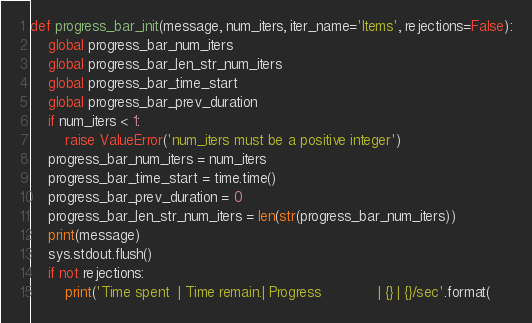Convert code to text. <code><loc_0><loc_0><loc_500><loc_500><_Python_>

def progress_bar_init(message, num_iters, iter_name='Items', rejections=False):
    global progress_bar_num_iters
    global progress_bar_len_str_num_iters
    global progress_bar_time_start
    global progress_bar_prev_duration
    if num_iters < 1:
        raise ValueError('num_iters must be a positive integer')
    progress_bar_num_iters = num_iters
    progress_bar_time_start = time.time()
    progress_bar_prev_duration = 0
    progress_bar_len_str_num_iters = len(str(progress_bar_num_iters))
    print(message)
    sys.stdout.flush()
    if not rejections:
        print('Time spent  | Time remain.| Progress             | {} | {}/sec'.format(</code> 